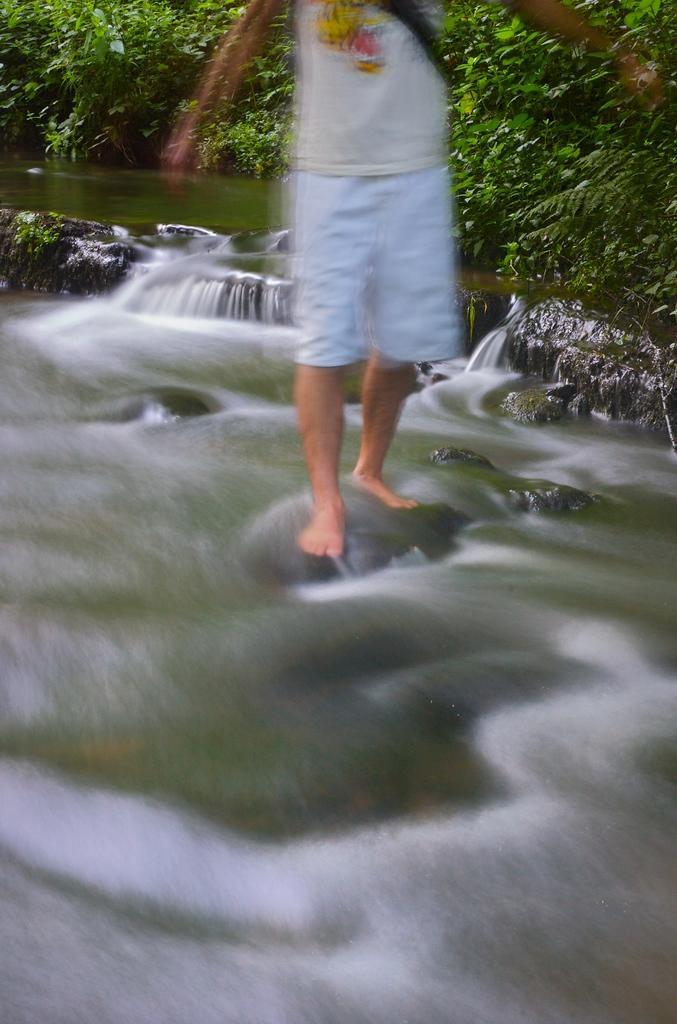Can you describe this image briefly? In this image I can see the person standing on the rock. I can see the water. In the background I can see many trees. 